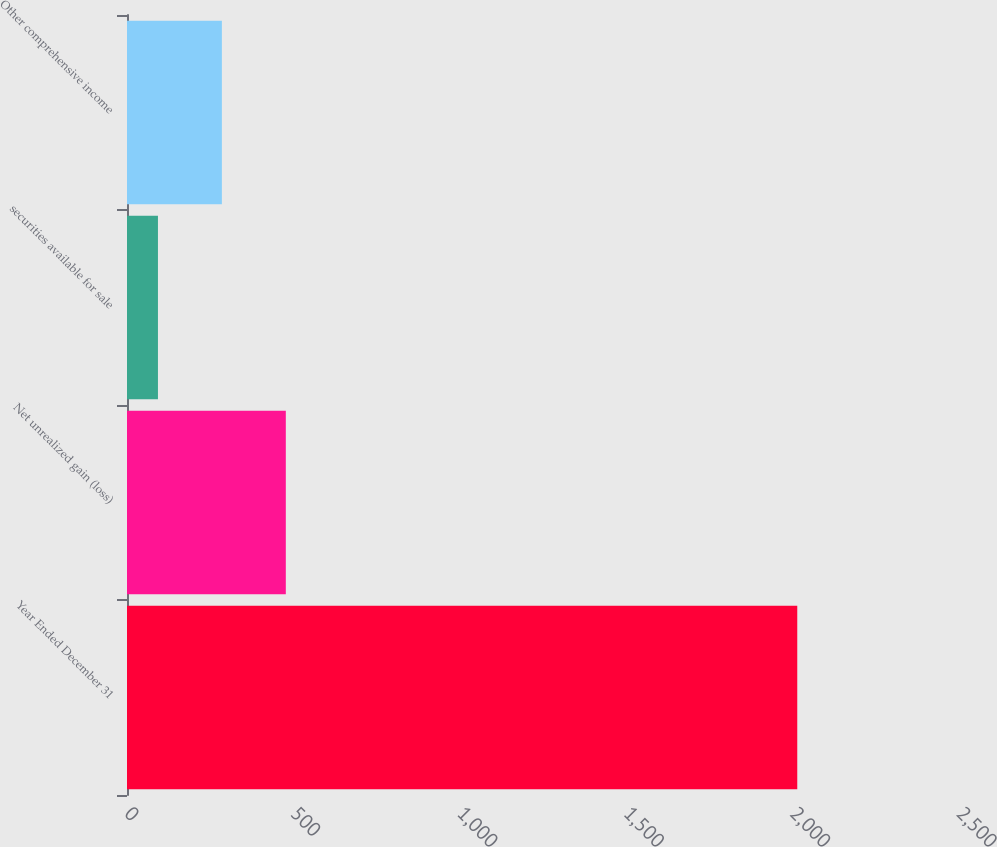<chart> <loc_0><loc_0><loc_500><loc_500><bar_chart><fcel>Year Ended December 31<fcel>Net unrealized gain (loss)<fcel>securities available for sale<fcel>Other comprehensive income<nl><fcel>2014<fcel>477.2<fcel>93<fcel>285.1<nl></chart> 